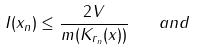Convert formula to latex. <formula><loc_0><loc_0><loc_500><loc_500>I ( x _ { n } ) \leq \frac { 2 V } { m ( K _ { r _ { n } } ( x ) ) } \quad a n d</formula> 